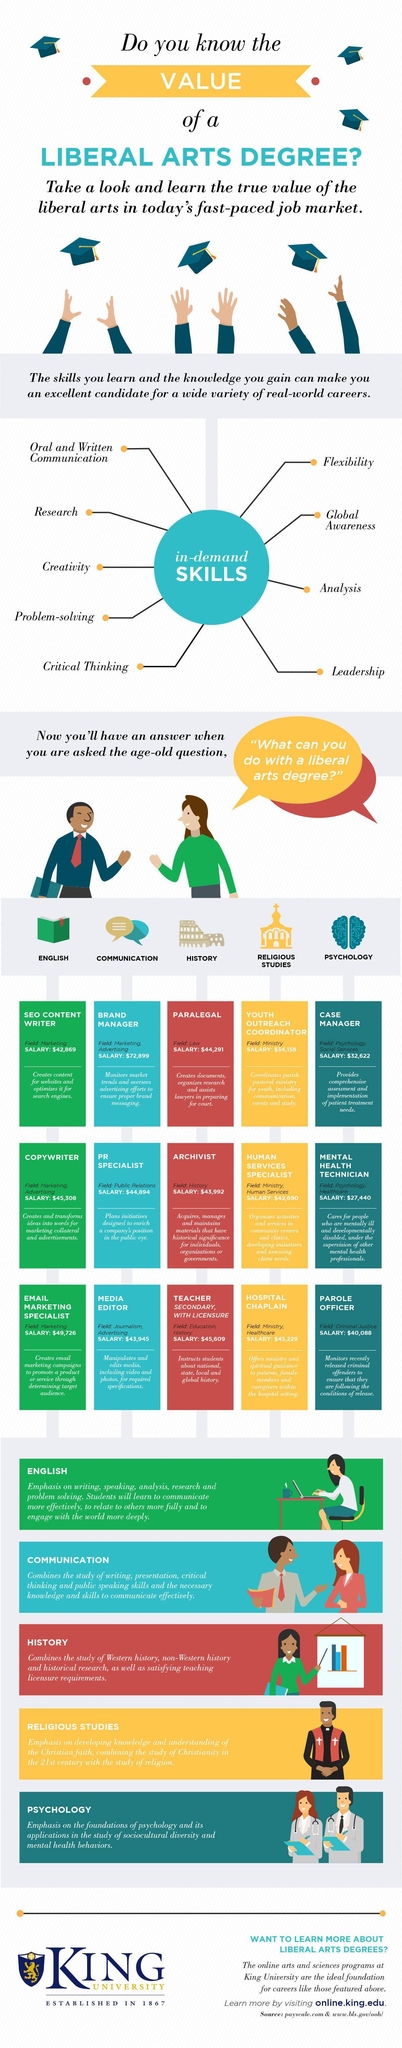What is the total number of in-demand skills?
Answer the question with a short phrase. 9 Archivist belongs to which field? History Copywriter belongs to which field? Marketing, Advertising Parole officer belongs to which field? Criminal Justice 